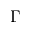Convert formula to latex. <formula><loc_0><loc_0><loc_500><loc_500>\Gamma</formula> 